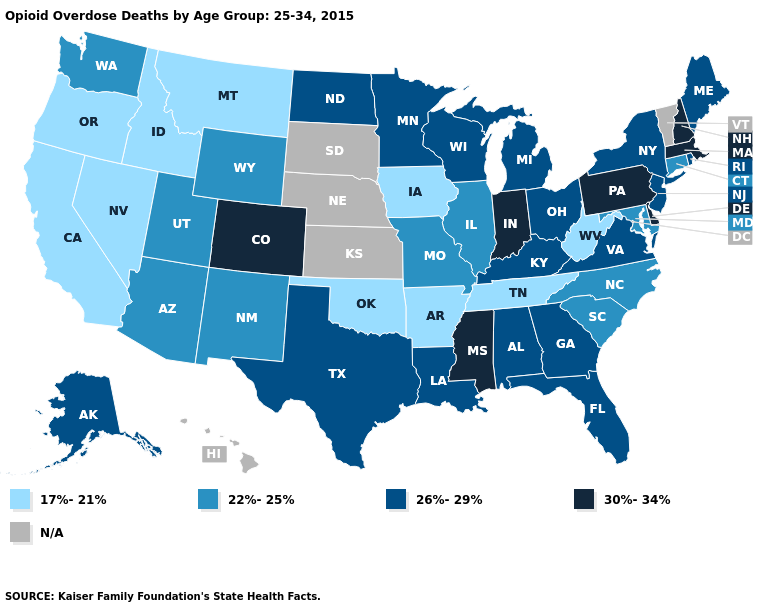Name the states that have a value in the range 22%-25%?
Give a very brief answer. Arizona, Connecticut, Illinois, Maryland, Missouri, New Mexico, North Carolina, South Carolina, Utah, Washington, Wyoming. Is the legend a continuous bar?
Give a very brief answer. No. Among the states that border Louisiana , which have the highest value?
Be succinct. Mississippi. Name the states that have a value in the range 17%-21%?
Quick response, please. Arkansas, California, Idaho, Iowa, Montana, Nevada, Oklahoma, Oregon, Tennessee, West Virginia. How many symbols are there in the legend?
Concise answer only. 5. Does Iowa have the lowest value in the MidWest?
Keep it brief. Yes. What is the value of South Dakota?
Give a very brief answer. N/A. What is the highest value in the Northeast ?
Concise answer only. 30%-34%. Name the states that have a value in the range 17%-21%?
Concise answer only. Arkansas, California, Idaho, Iowa, Montana, Nevada, Oklahoma, Oregon, Tennessee, West Virginia. Name the states that have a value in the range 30%-34%?
Write a very short answer. Colorado, Delaware, Indiana, Massachusetts, Mississippi, New Hampshire, Pennsylvania. Does the first symbol in the legend represent the smallest category?
Give a very brief answer. Yes. What is the lowest value in states that border Washington?
Quick response, please. 17%-21%. Does California have the lowest value in the West?
Answer briefly. Yes. Name the states that have a value in the range 17%-21%?
Be succinct. Arkansas, California, Idaho, Iowa, Montana, Nevada, Oklahoma, Oregon, Tennessee, West Virginia. Does Delaware have the highest value in the USA?
Concise answer only. Yes. 